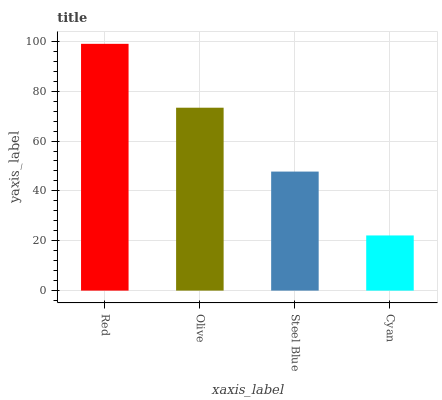Is Cyan the minimum?
Answer yes or no. Yes. Is Red the maximum?
Answer yes or no. Yes. Is Olive the minimum?
Answer yes or no. No. Is Olive the maximum?
Answer yes or no. No. Is Red greater than Olive?
Answer yes or no. Yes. Is Olive less than Red?
Answer yes or no. Yes. Is Olive greater than Red?
Answer yes or no. No. Is Red less than Olive?
Answer yes or no. No. Is Olive the high median?
Answer yes or no. Yes. Is Steel Blue the low median?
Answer yes or no. Yes. Is Steel Blue the high median?
Answer yes or no. No. Is Cyan the low median?
Answer yes or no. No. 